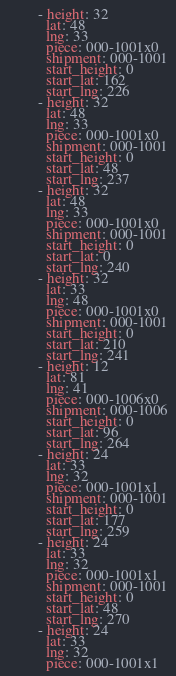Convert code to text. <code><loc_0><loc_0><loc_500><loc_500><_YAML_>        - height: 32
          lat: 48
          lng: 33
          piece: 000-1001x0
          shipment: 000-1001
          start_height: 0
          start_lat: 162
          start_lng: 226
        - height: 32
          lat: 48
          lng: 33
          piece: 000-1001x0
          shipment: 000-1001
          start_height: 0
          start_lat: 48
          start_lng: 237
        - height: 32
          lat: 48
          lng: 33
          piece: 000-1001x0
          shipment: 000-1001
          start_height: 0
          start_lat: 0
          start_lng: 240
        - height: 32
          lat: 33
          lng: 48
          piece: 000-1001x0
          shipment: 000-1001
          start_height: 0
          start_lat: 210
          start_lng: 241
        - height: 12
          lat: 81
          lng: 41
          piece: 000-1006x0
          shipment: 000-1006
          start_height: 0
          start_lat: 96
          start_lng: 264
        - height: 24
          lat: 33
          lng: 32
          piece: 000-1001x1
          shipment: 000-1001
          start_height: 0
          start_lat: 177
          start_lng: 259
        - height: 24
          lat: 33
          lng: 32
          piece: 000-1001x1
          shipment: 000-1001
          start_height: 0
          start_lat: 48
          start_lng: 270
        - height: 24
          lat: 33
          lng: 32
          piece: 000-1001x1</code> 